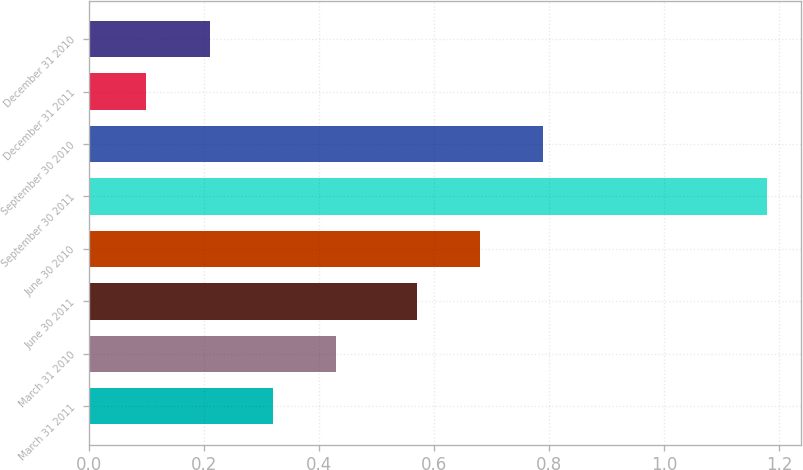Convert chart to OTSL. <chart><loc_0><loc_0><loc_500><loc_500><bar_chart><fcel>March 31 2011<fcel>March 31 2010<fcel>June 30 2011<fcel>June 30 2010<fcel>September 30 2011<fcel>September 30 2010<fcel>December 31 2011<fcel>December 31 2010<nl><fcel>0.32<fcel>0.43<fcel>0.57<fcel>0.68<fcel>1.18<fcel>0.79<fcel>0.1<fcel>0.21<nl></chart> 